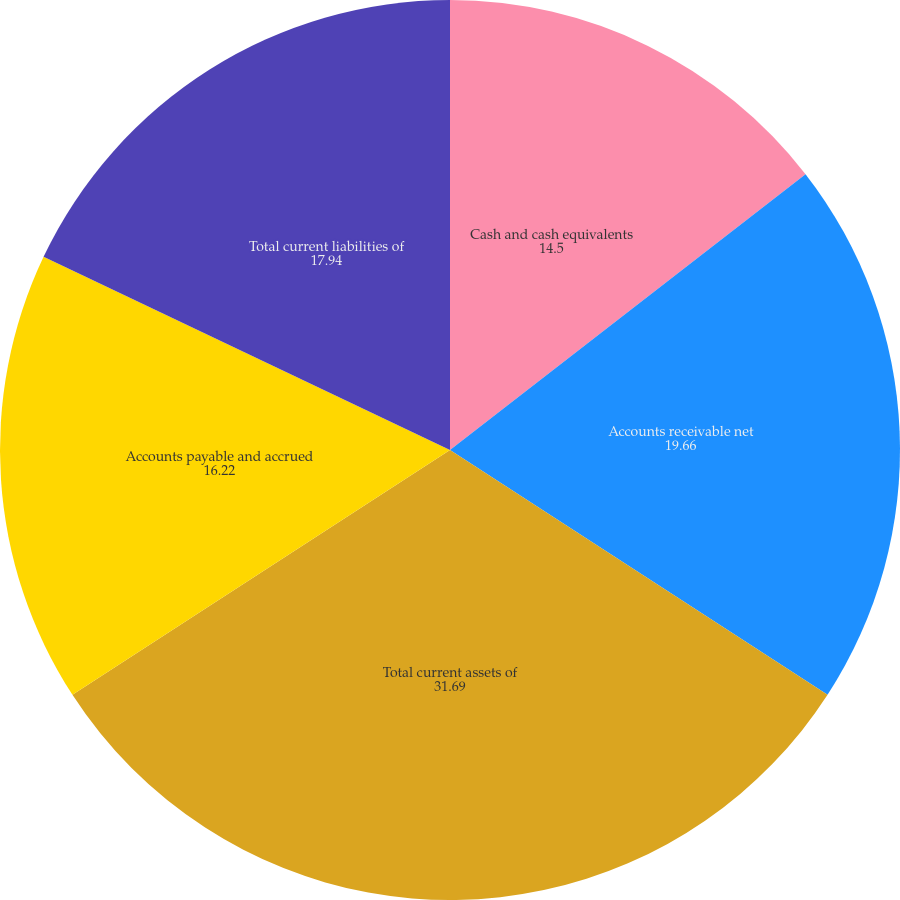Convert chart. <chart><loc_0><loc_0><loc_500><loc_500><pie_chart><fcel>Cash and cash equivalents<fcel>Accounts receivable net<fcel>Total current assets of<fcel>Accounts payable and accrued<fcel>Total current liabilities of<nl><fcel>14.5%<fcel>19.66%<fcel>31.69%<fcel>16.22%<fcel>17.94%<nl></chart> 